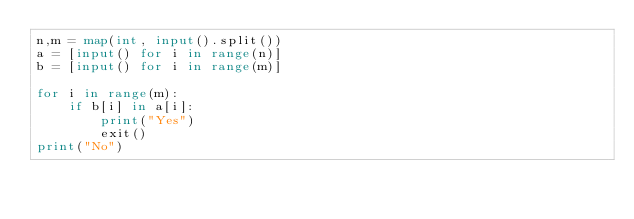<code> <loc_0><loc_0><loc_500><loc_500><_Python_>n,m = map(int, input().split())
a = [input() for i in range(n)]
b = [input() for i in range(m)]

for i in range(m):
    if b[i] in a[i]:
        print("Yes")
        exit()
print("No")</code> 